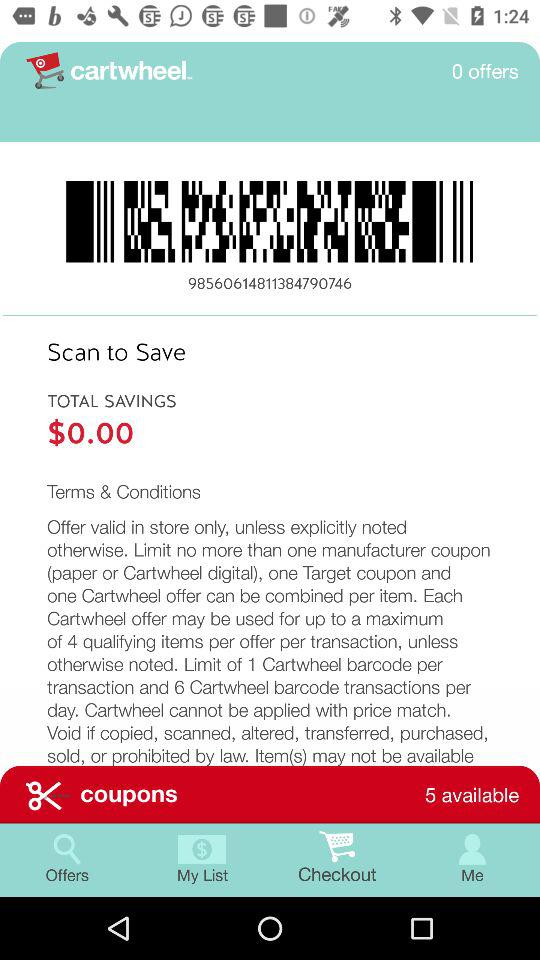How much is the total saving? The total savings is $0. 